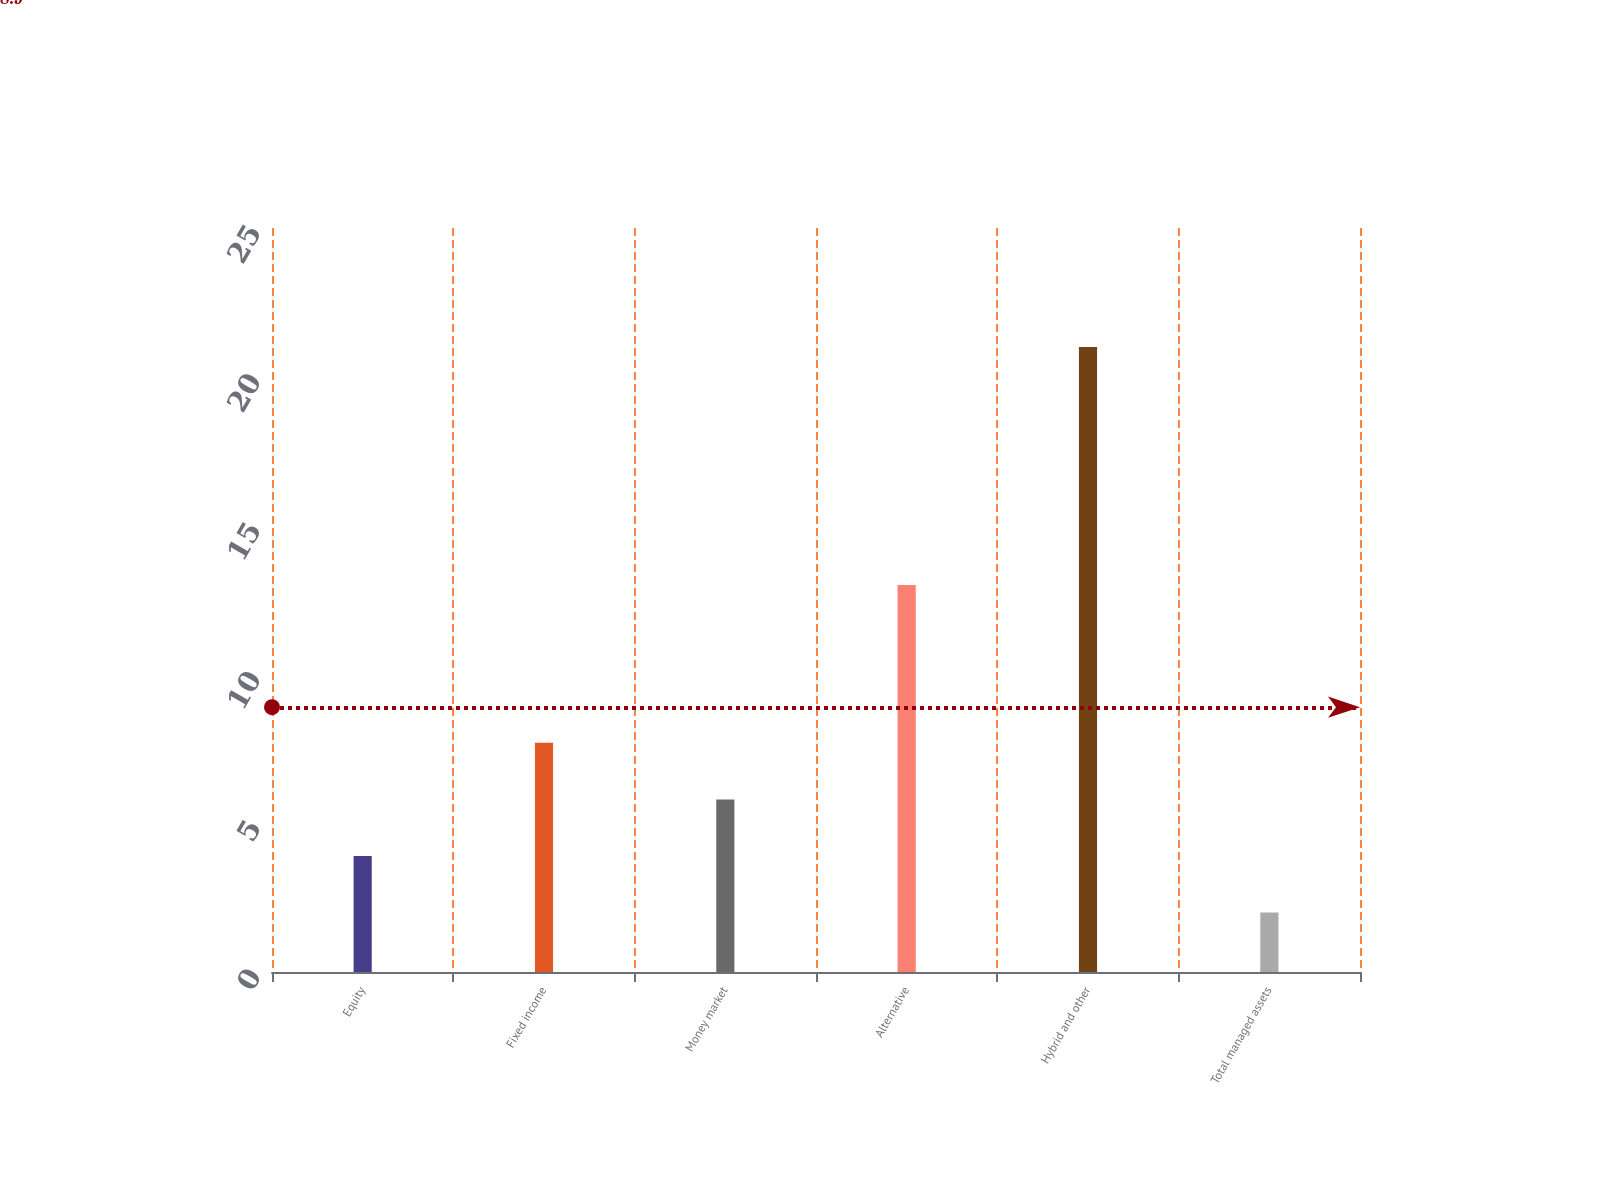<chart> <loc_0><loc_0><loc_500><loc_500><bar_chart><fcel>Equity<fcel>Fixed income<fcel>Money market<fcel>Alternative<fcel>Hybrid and other<fcel>Total managed assets<nl><fcel>3.9<fcel>7.7<fcel>5.8<fcel>13<fcel>21<fcel>2<nl></chart> 